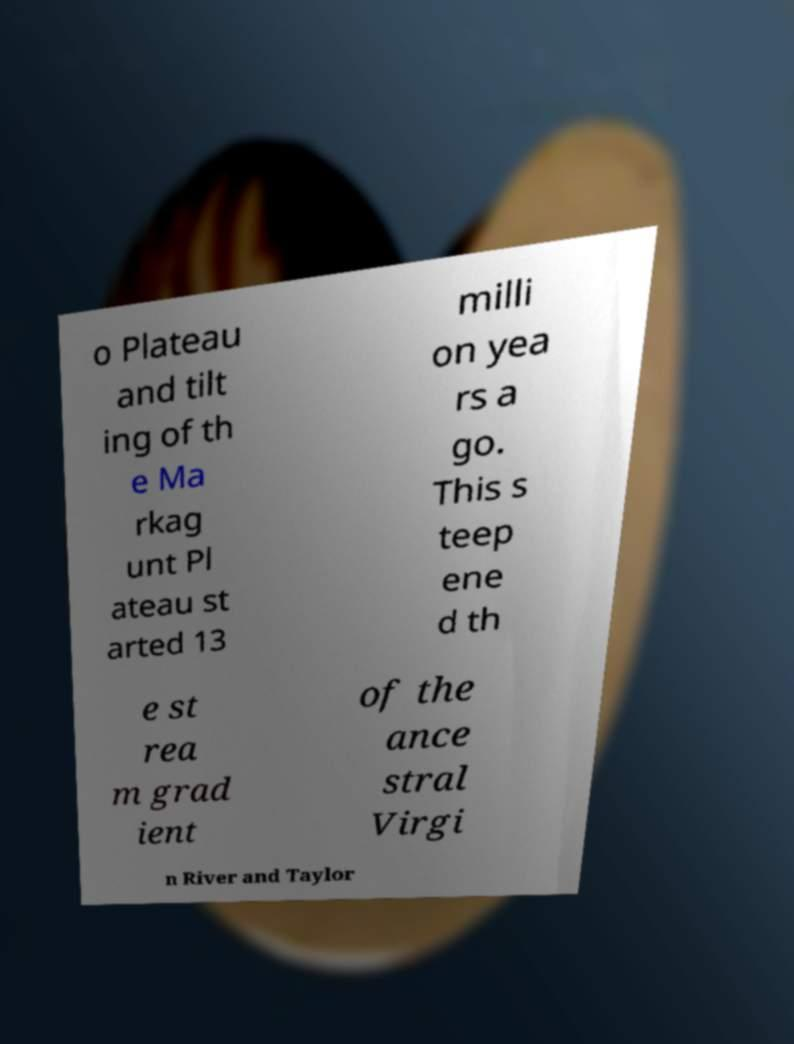I need the written content from this picture converted into text. Can you do that? o Plateau and tilt ing of th e Ma rkag unt Pl ateau st arted 13 milli on yea rs a go. This s teep ene d th e st rea m grad ient of the ance stral Virgi n River and Taylor 